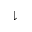<formula> <loc_0><loc_0><loc_500><loc_500>\downharpoonright</formula> 